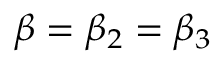Convert formula to latex. <formula><loc_0><loc_0><loc_500><loc_500>\beta = \beta _ { 2 } = \beta _ { 3 }</formula> 